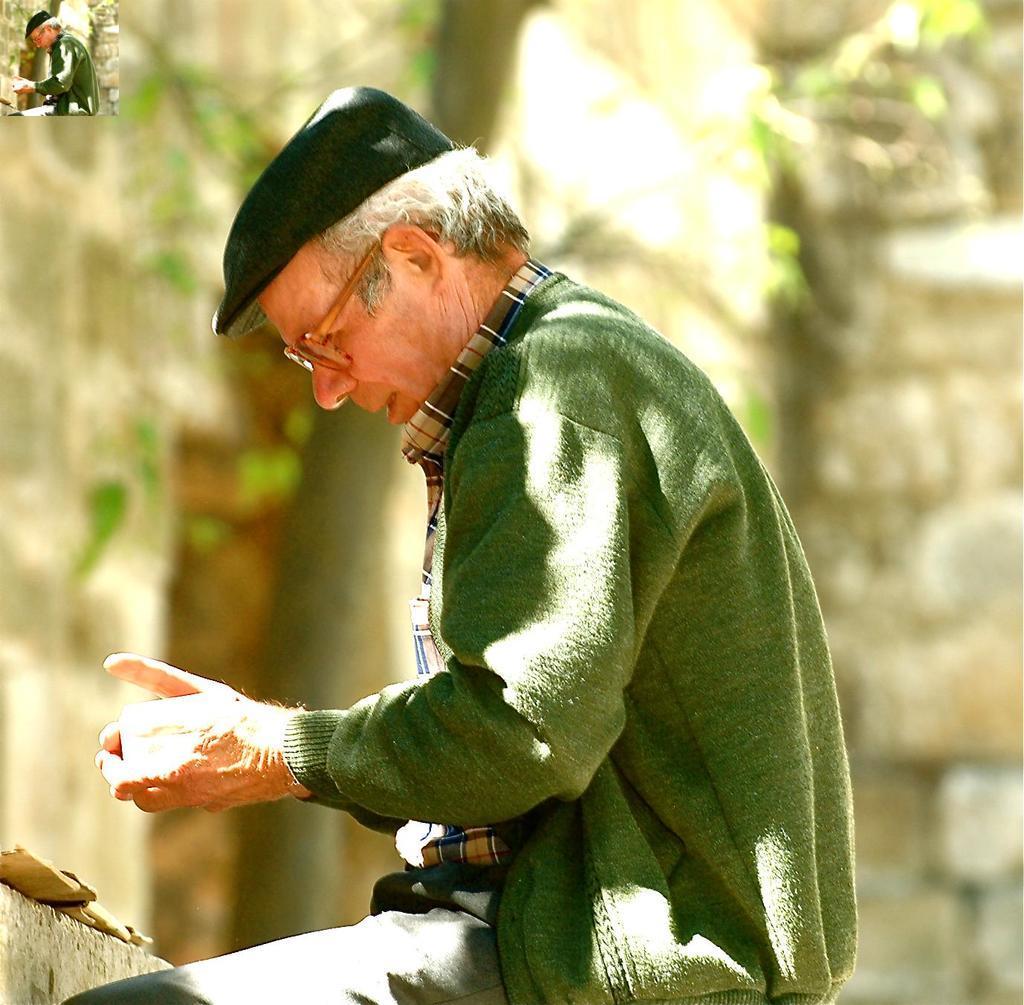How would you summarize this image in a sentence or two? In this image we can see a man sitting. On the left side we can see the same miniature image of that person. On the backside we can see a tree and a wall. 